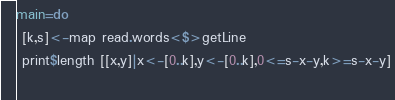<code> <loc_0><loc_0><loc_500><loc_500><_Haskell_>main=do
 [k,s]<-map read.words<$>getLine
 print$length [[x,y]|x<-[0..k],y<-[0..k],0<=s-x-y,k>=s-x-y]
 </code> 